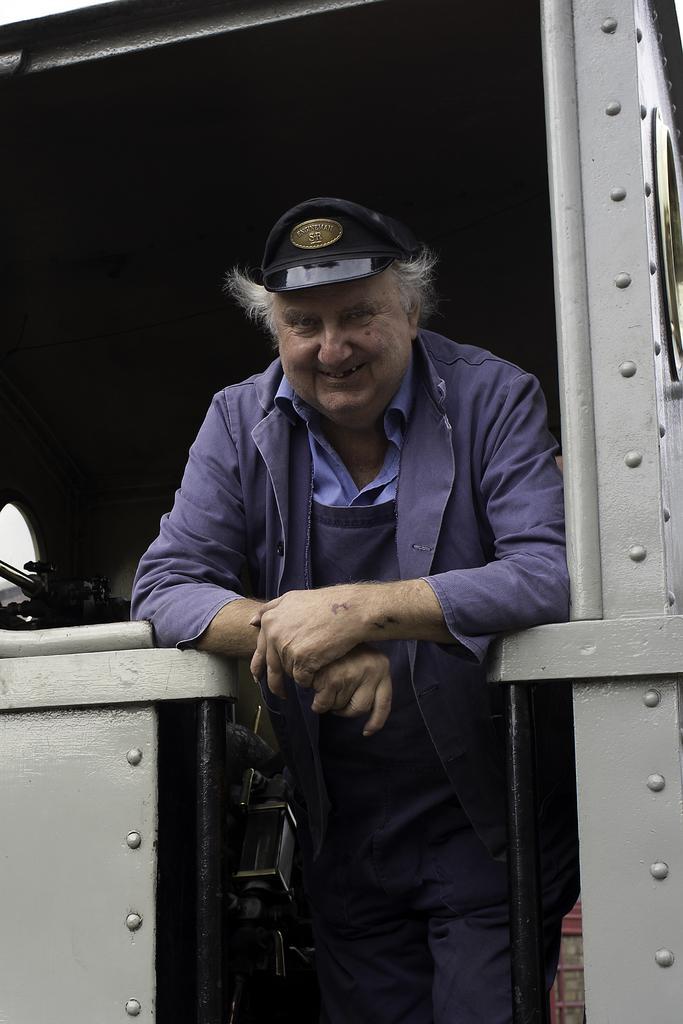In one or two sentences, can you explain what this image depicts? In this picture, there is a man standing on a metal structure. He is wearing a purple jacket, cap and trousers. 